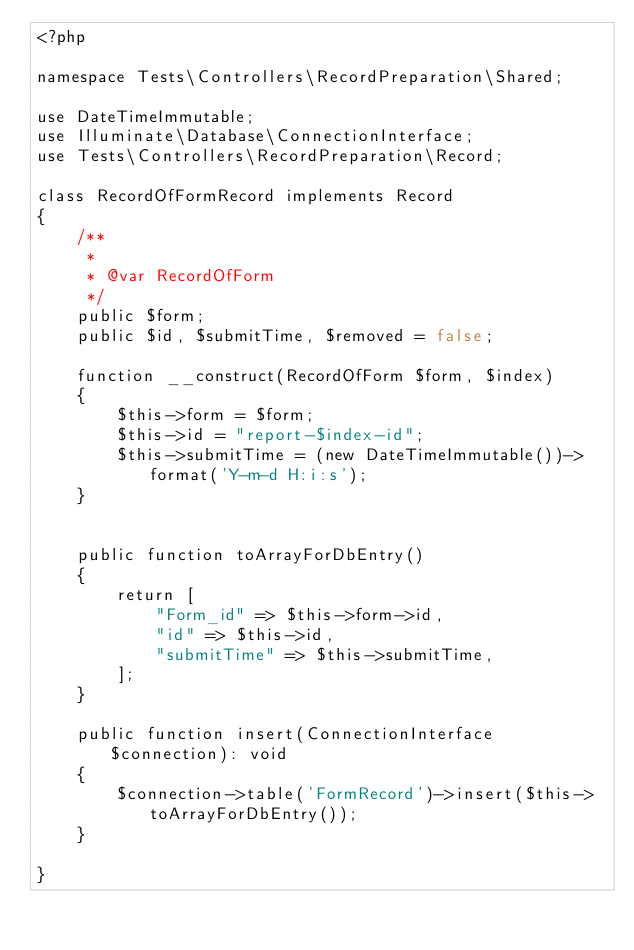Convert code to text. <code><loc_0><loc_0><loc_500><loc_500><_PHP_><?php

namespace Tests\Controllers\RecordPreparation\Shared;

use DateTimeImmutable;
use Illuminate\Database\ConnectionInterface;
use Tests\Controllers\RecordPreparation\Record;

class RecordOfFormRecord implements Record
{
    /**
     *
     * @var RecordOfForm
     */
    public $form;
    public $id, $submitTime, $removed = false;
    
    function __construct(RecordOfForm $form, $index)
    {
        $this->form = $form;
        $this->id = "report-$index-id";
        $this->submitTime = (new DateTimeImmutable())->format('Y-m-d H:i:s');
    }

    
    public function toArrayForDbEntry()
    {
        return [
            "Form_id" => $this->form->id,
            "id" => $this->id,
            "submitTime" => $this->submitTime,
        ];
    }
    
    public function insert(ConnectionInterface $connection): void
    {
        $connection->table('FormRecord')->insert($this->toArrayForDbEntry());
    }

}
</code> 